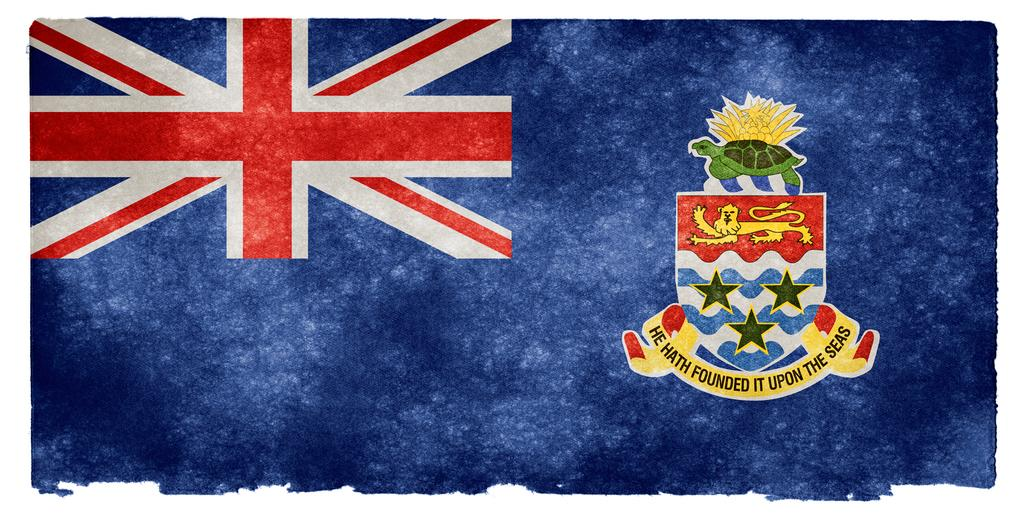What type of image is this? The image appears to be an edited photo. What can be seen in the image besides the edited nature of the photo? There is a flag visible in the image. Can you see any sea creatures swimming in the image? There is no sea or sea creatures visible in the image. Is there a chain present in the image? There is no chain present in the image. 